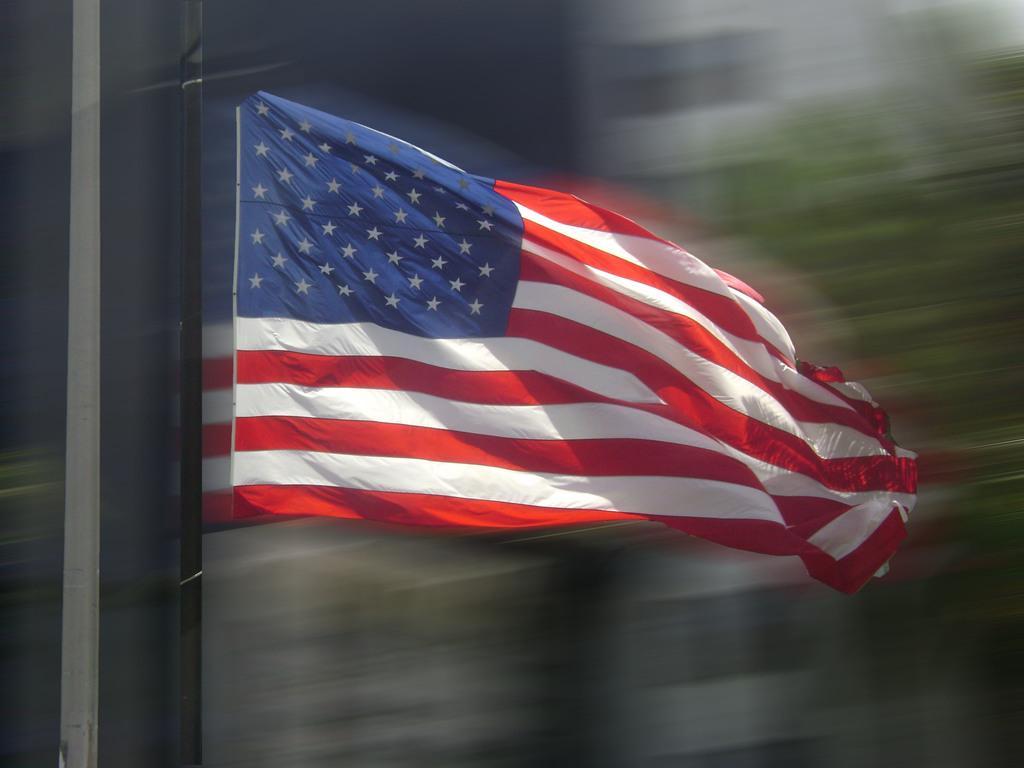How would you summarize this image in a sentence or two? In this picture, we see a flag pole and a flag in white, red and blue color. On the left side, we see a grey color building. There are trees and the buildings in the background. This picture is blurred in the background. 